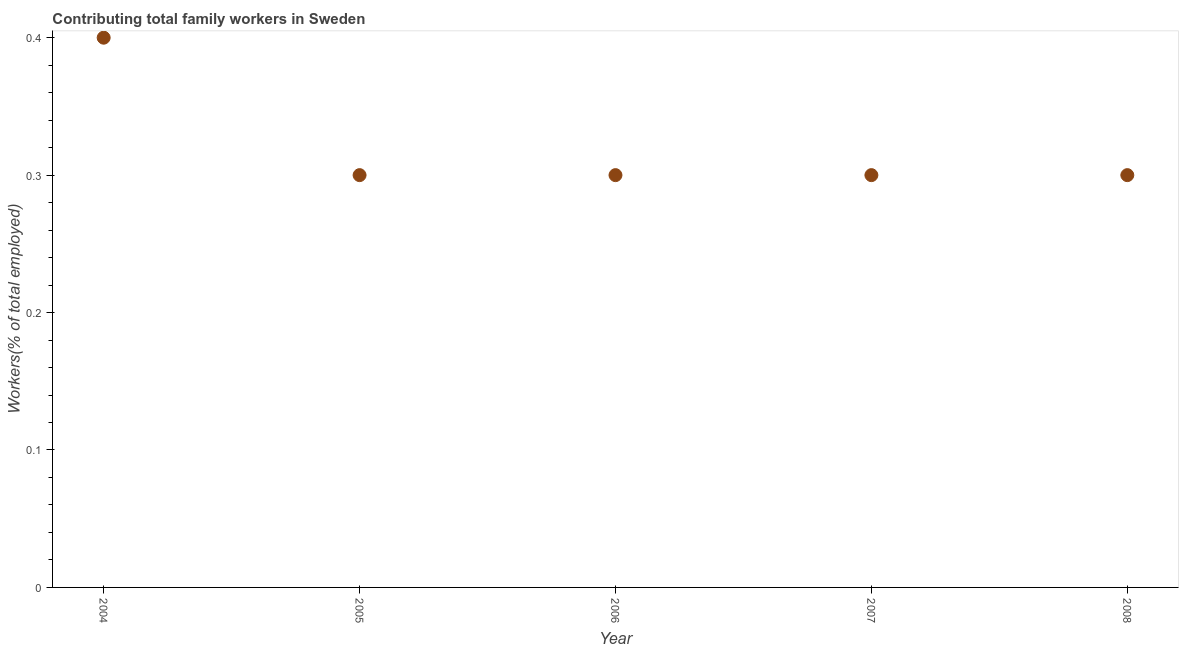What is the contributing family workers in 2006?
Your answer should be very brief. 0.3. Across all years, what is the maximum contributing family workers?
Your answer should be compact. 0.4. Across all years, what is the minimum contributing family workers?
Offer a terse response. 0.3. In which year was the contributing family workers minimum?
Keep it short and to the point. 2005. What is the sum of the contributing family workers?
Provide a short and direct response. 1.6. What is the average contributing family workers per year?
Your answer should be very brief. 0.32. What is the median contributing family workers?
Keep it short and to the point. 0.3. What is the ratio of the contributing family workers in 2004 to that in 2006?
Ensure brevity in your answer.  1.33. What is the difference between the highest and the second highest contributing family workers?
Your answer should be very brief. 0.1. What is the difference between the highest and the lowest contributing family workers?
Give a very brief answer. 0.1. In how many years, is the contributing family workers greater than the average contributing family workers taken over all years?
Keep it short and to the point. 1. What is the difference between two consecutive major ticks on the Y-axis?
Offer a terse response. 0.1. Are the values on the major ticks of Y-axis written in scientific E-notation?
Give a very brief answer. No. Does the graph contain any zero values?
Offer a terse response. No. Does the graph contain grids?
Provide a succinct answer. No. What is the title of the graph?
Provide a short and direct response. Contributing total family workers in Sweden. What is the label or title of the Y-axis?
Offer a terse response. Workers(% of total employed). What is the Workers(% of total employed) in 2004?
Give a very brief answer. 0.4. What is the Workers(% of total employed) in 2005?
Your answer should be compact. 0.3. What is the Workers(% of total employed) in 2006?
Provide a succinct answer. 0.3. What is the Workers(% of total employed) in 2007?
Offer a very short reply. 0.3. What is the Workers(% of total employed) in 2008?
Provide a succinct answer. 0.3. What is the difference between the Workers(% of total employed) in 2004 and 2006?
Provide a short and direct response. 0.1. What is the difference between the Workers(% of total employed) in 2005 and 2007?
Provide a short and direct response. 0. What is the difference between the Workers(% of total employed) in 2005 and 2008?
Provide a succinct answer. 0. What is the difference between the Workers(% of total employed) in 2006 and 2007?
Ensure brevity in your answer.  0. What is the ratio of the Workers(% of total employed) in 2004 to that in 2005?
Provide a succinct answer. 1.33. What is the ratio of the Workers(% of total employed) in 2004 to that in 2006?
Your answer should be compact. 1.33. What is the ratio of the Workers(% of total employed) in 2004 to that in 2007?
Offer a very short reply. 1.33. What is the ratio of the Workers(% of total employed) in 2004 to that in 2008?
Ensure brevity in your answer.  1.33. What is the ratio of the Workers(% of total employed) in 2005 to that in 2007?
Ensure brevity in your answer.  1. What is the ratio of the Workers(% of total employed) in 2005 to that in 2008?
Give a very brief answer. 1. What is the ratio of the Workers(% of total employed) in 2006 to that in 2008?
Offer a terse response. 1. 